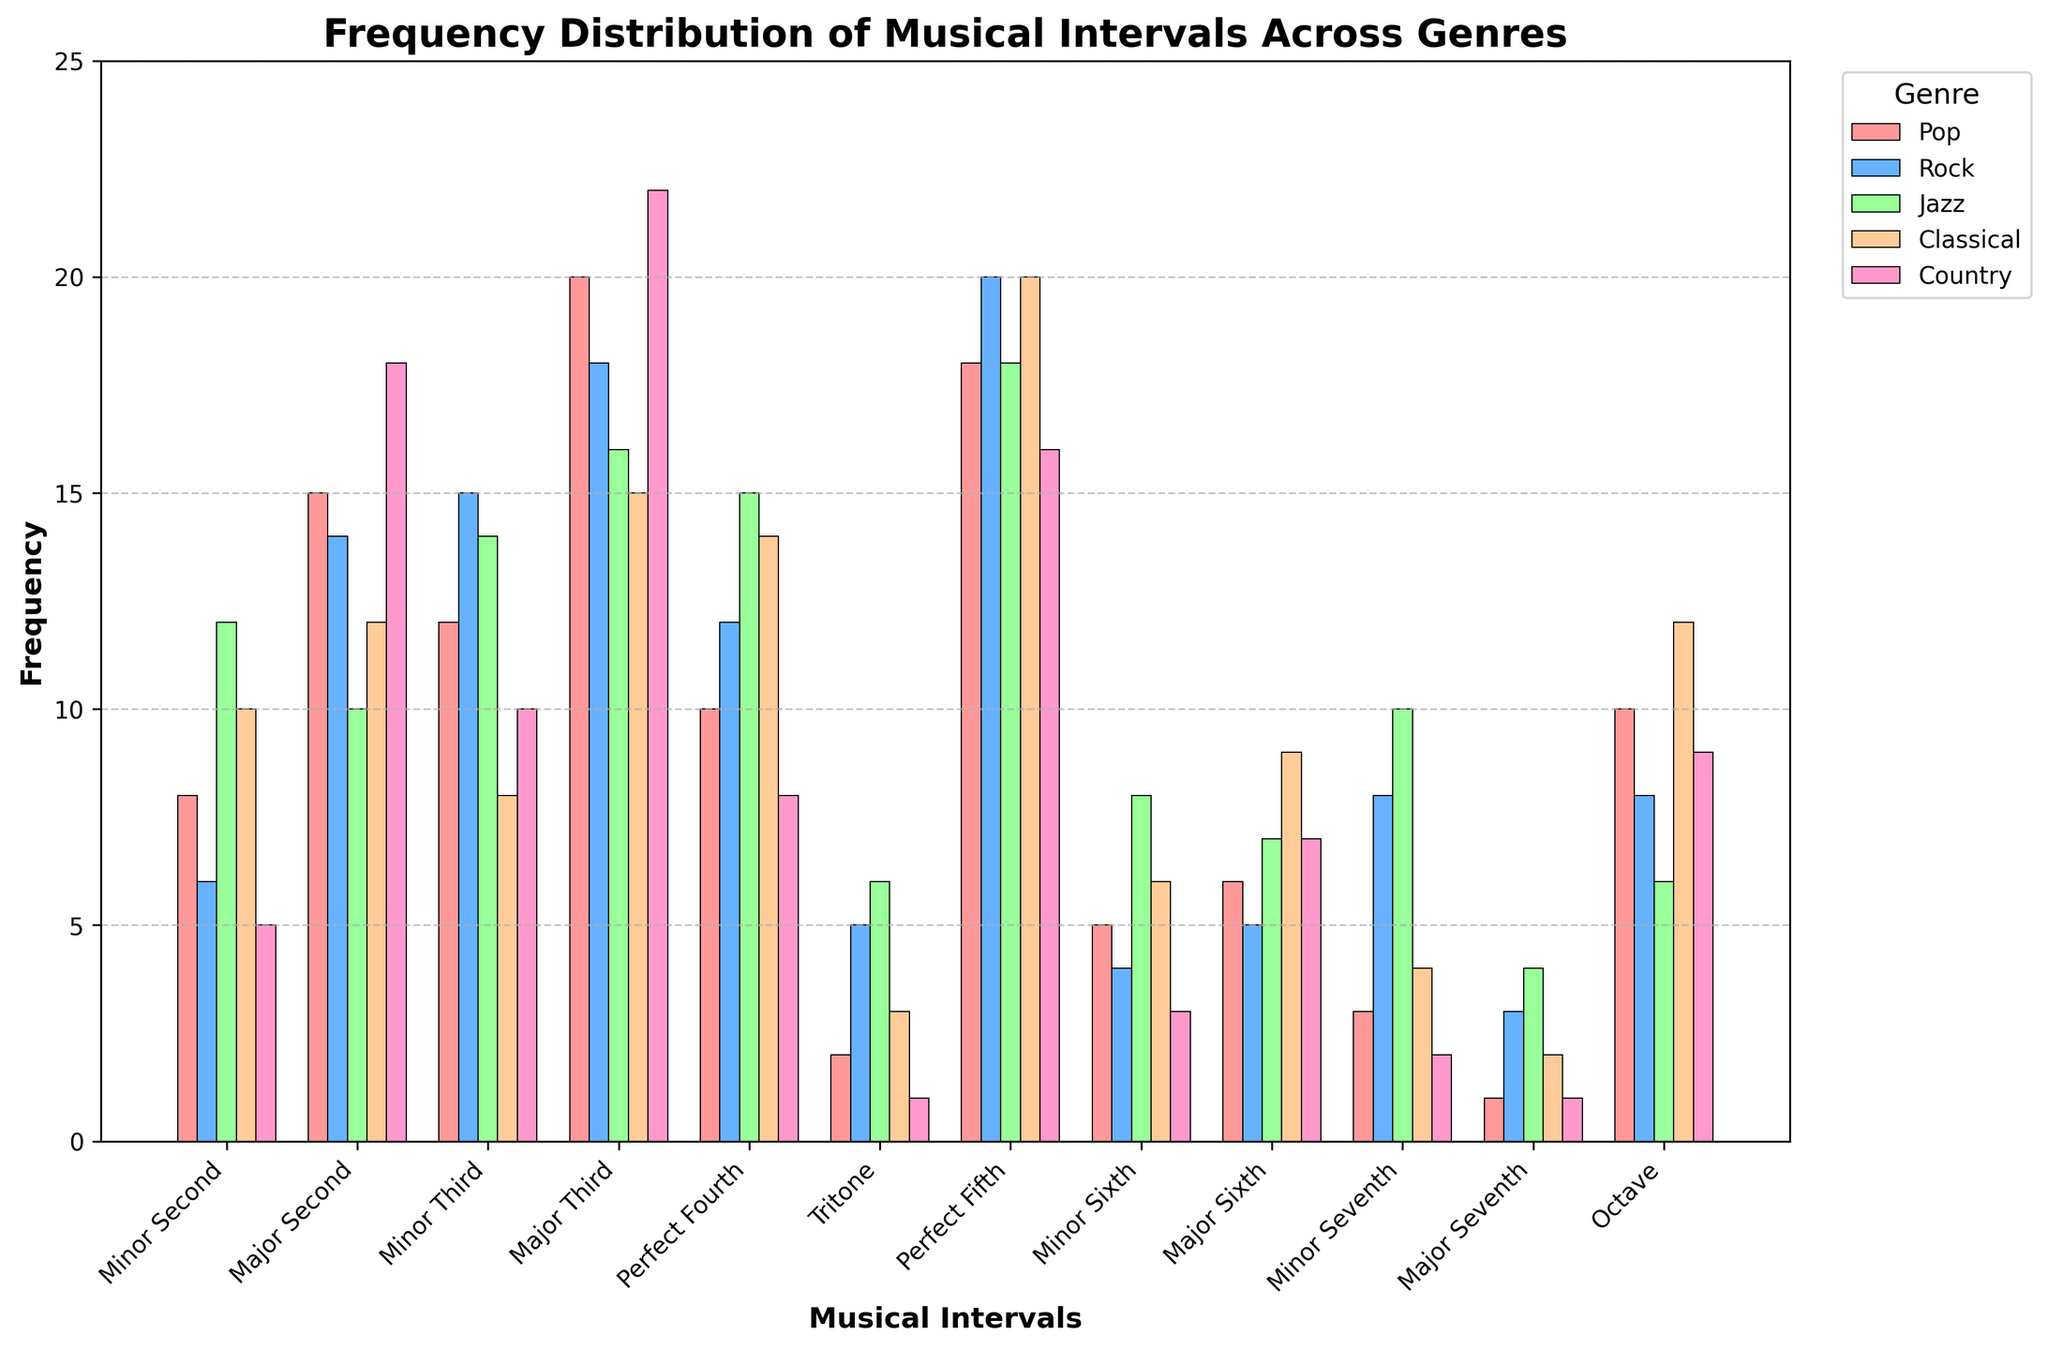What's the most common musical interval in Pop music? By visually inspecting the bars representing Pop music, the highest bar corresponds to the Major Third interval.
Answer: Major Third Across all genres, which musical interval appears most frequently? To find this, we identify the highest bar across all genres by visually comparing their heights. The Major Third in the Country genre has the tallest bar.
Answer: Major Third in Country Which genres have frequency values for the Minor Sixth interval that are greater than 5? Visually inspect the bars for the Minor Sixth interval across all genres. Both Jazz and Classical have values greater than 5.
Answer: Jazz, Classical What is the difference between the highest and lowest uses of Perfect Fifth across genres? The highest frequency of Perfect Fifth is 20 (Rock and Classical), and the lowest is 16 (Country). The difference is \(20 - 16 = 4\).
Answer: 4 If you sum the frequencies of Major Third and Perfect Fifth intervals in Jazz, what do you get? The frequencies are 16 (Major Third) and 18 (Perfect Fifth). When summed, \(16 + 18 = 34\).
Answer: 34 Which interval has the smallest frequency in Rock music? The shortest bar in the Rock music category corresponds to the Major Seventh interval.
Answer: Major Seventh In which genre is the Tritone interval used more frequently than the Minor Seventh interval? By comparing the bars for Tritone and Minor Seventh for each genre, Rock and Jazz have higher values for Tritone compared to Minor Seventh.
Answer: Rock, Jazz How many intervals have the same frequency (10) as the Minor Third in Classical? Visually identify and count the intervals with a frequency of 10. Minor Second (Jazz), Major Second (Jazz), and Perfect Fourth (Jazz) also have a frequency of 10.
Answer: 3 What's the difference in the frequency of the Major Second interval between Pop and Country music? The frequency of Major Second is 15 in Pop and 18 in Country. The difference is \(18 - 15 = 3\).
Answer: 3 